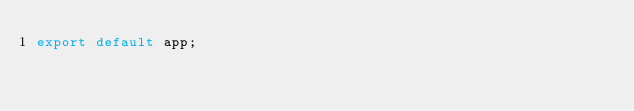<code> <loc_0><loc_0><loc_500><loc_500><_TypeScript_>export default app;
</code> 